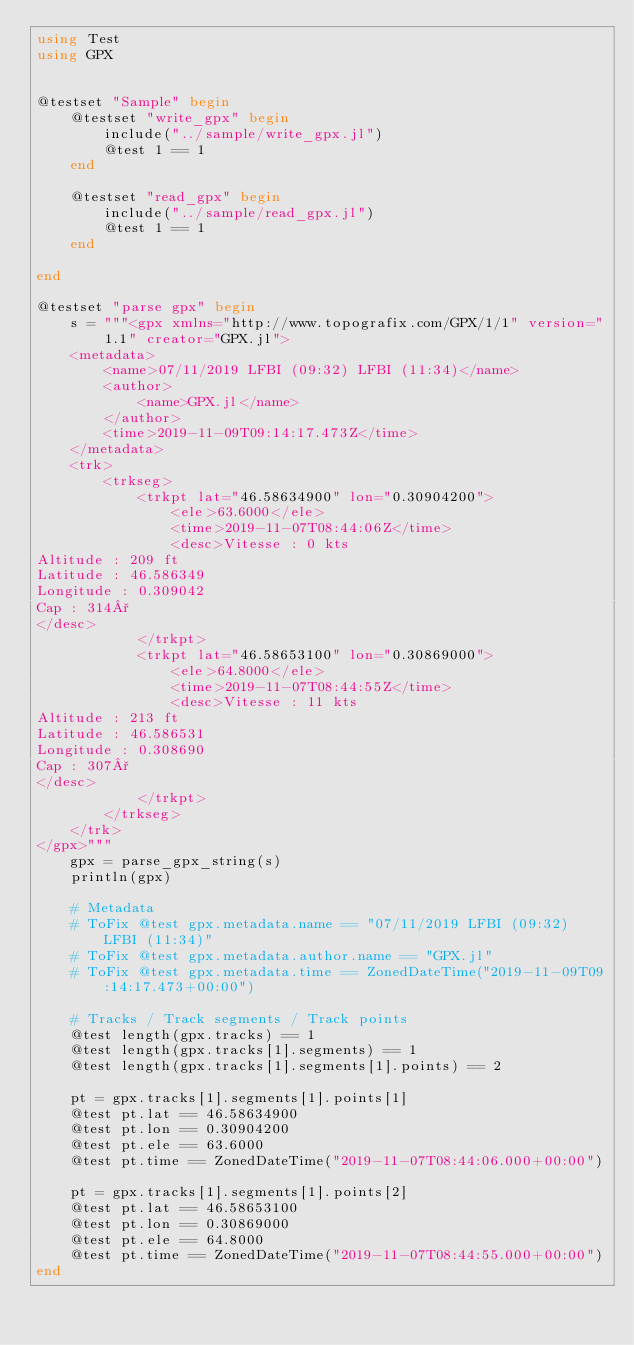<code> <loc_0><loc_0><loc_500><loc_500><_Julia_>using Test
using GPX


@testset "Sample" begin
    @testset "write_gpx" begin
		include("../sample/write_gpx.jl")
		@test 1 == 1
    end

    @testset "read_gpx" begin
		include("../sample/read_gpx.jl")
		@test 1 == 1
    end

end

@testset "parse gpx" begin
    s = """<gpx xmlns="http://www.topografix.com/GPX/1/1" version="1.1" creator="GPX.jl">
	<metadata>
		<name>07/11/2019 LFBI (09:32) LFBI (11:34)</name>
		<author>
			<name>GPX.jl</name>
		</author>
		<time>2019-11-09T09:14:17.473Z</time>
	</metadata>
	<trk>
		<trkseg>
			<trkpt lat="46.58634900" lon="0.30904200">
				<ele>63.6000</ele>
				<time>2019-11-07T08:44:06Z</time>
				<desc>Vitesse : 0 kts
Altitude : 209 ft
Latitude : 46.586349
Longitude : 0.309042
Cap : 314°
</desc>
			</trkpt>
			<trkpt lat="46.58653100" lon="0.30869000">
				<ele>64.8000</ele>
				<time>2019-11-07T08:44:55Z</time>
				<desc>Vitesse : 11 kts
Altitude : 213 ft
Latitude : 46.586531
Longitude : 0.308690
Cap : 307°
</desc>
            </trkpt>
        </trkseg>
    </trk>
</gpx>"""
    gpx = parse_gpx_string(s)
	println(gpx)

	# Metadata
	# ToFix @test gpx.metadata.name == "07/11/2019 LFBI (09:32) LFBI (11:34)"
	# ToFix @test gpx.metadata.author.name == "GPX.jl"
	# ToFix @test gpx.metadata.time == ZonedDateTime("2019-11-09T09:14:17.473+00:00")

	# Tracks / Track segments / Track points
	@test length(gpx.tracks) == 1
	@test length(gpx.tracks[1].segments) == 1
	@test length(gpx.tracks[1].segments[1].points) == 2

	pt = gpx.tracks[1].segments[1].points[1]
	@test pt.lat == 46.58634900
	@test pt.lon == 0.30904200
	@test pt.ele == 63.6000
	@test pt.time == ZonedDateTime("2019-11-07T08:44:06.000+00:00")

	pt = gpx.tracks[1].segments[1].points[2]
	@test pt.lat == 46.58653100
	@test pt.lon == 0.30869000
	@test pt.ele == 64.8000
	@test pt.time == ZonedDateTime("2019-11-07T08:44:55.000+00:00")
end
</code> 